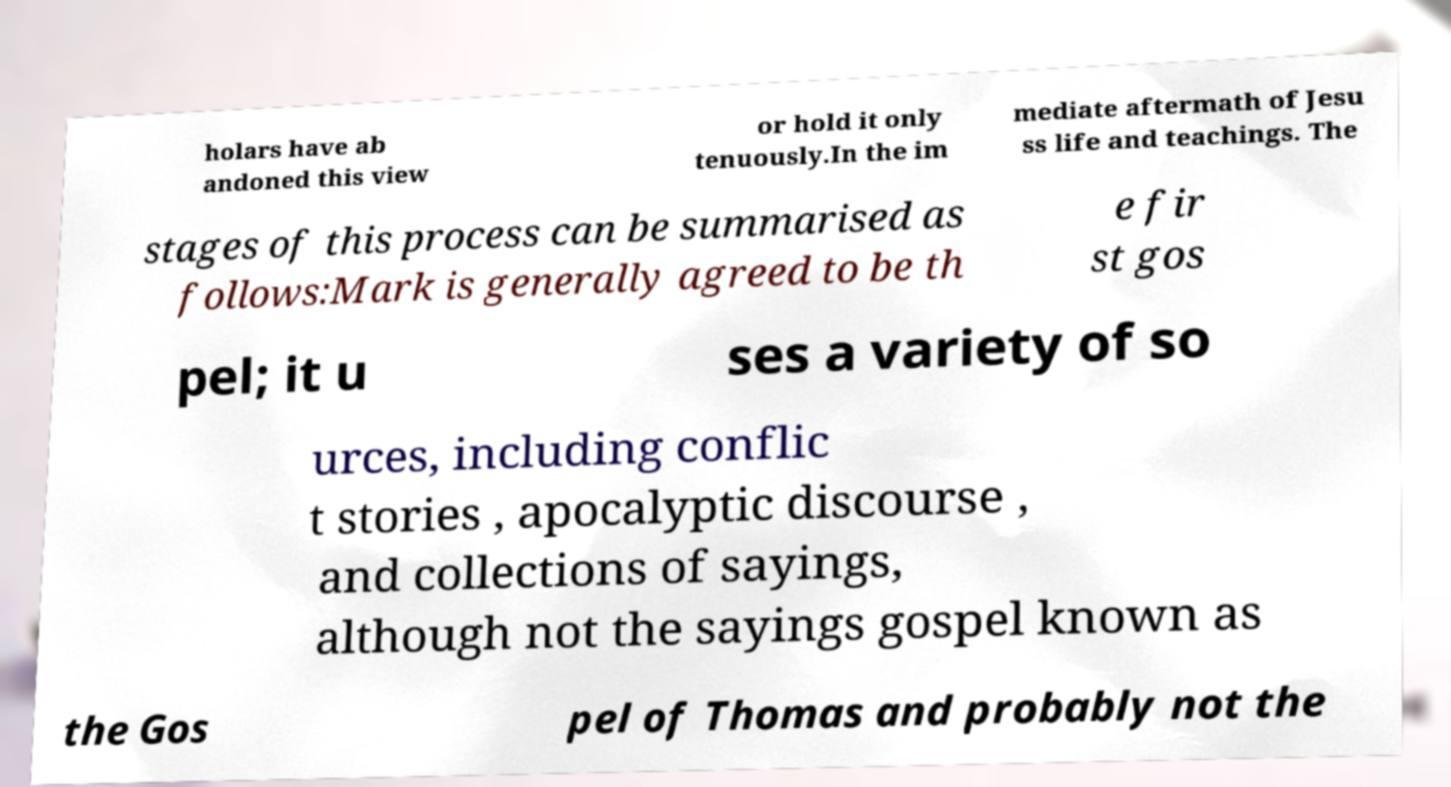What messages or text are displayed in this image? I need them in a readable, typed format. holars have ab andoned this view or hold it only tenuously.In the im mediate aftermath of Jesu ss life and teachings. The stages of this process can be summarised as follows:Mark is generally agreed to be th e fir st gos pel; it u ses a variety of so urces, including conflic t stories , apocalyptic discourse , and collections of sayings, although not the sayings gospel known as the Gos pel of Thomas and probably not the 